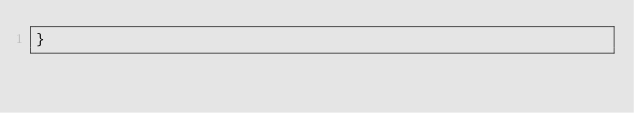<code> <loc_0><loc_0><loc_500><loc_500><_C_>}
</code> 